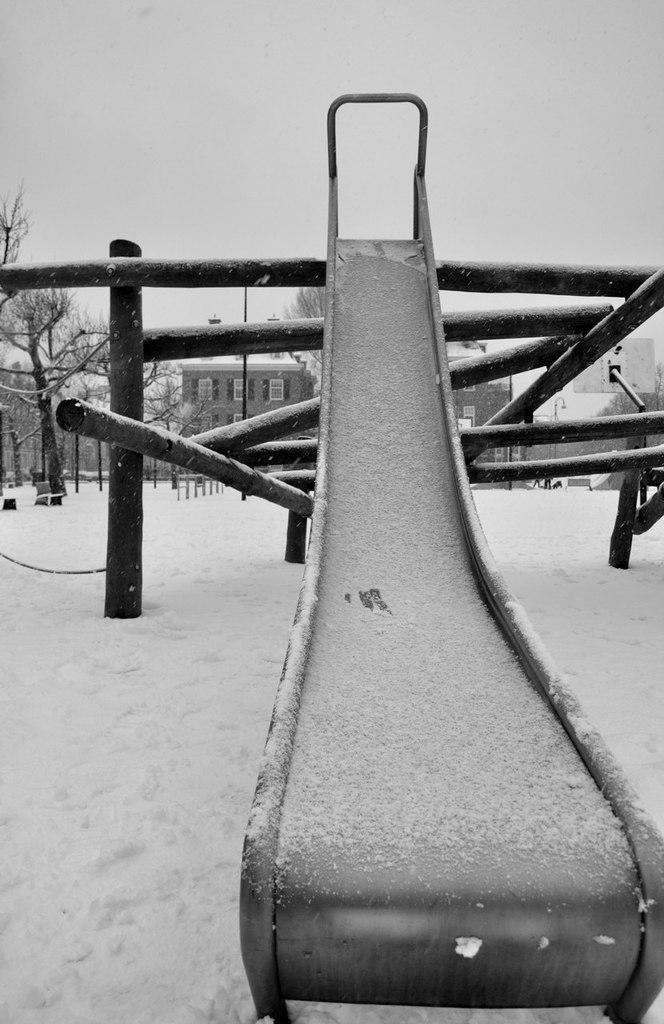What is the color scheme of the image? The image is black and white. What type of objects can be seen in the image? There are metal rods and other objects in the image. What type of playground equipment is present in the image? There is a slide in the image. What can be seen in the background of the image? Buildings and trees are visible in the background. What is the condition of the ground in the image? The ground is covered in snow. What type of produce is being harvested by the giants in the image? There are no giants or produce present in the image. What type of creature is interacting with the slide in the image? There is no creature interacting with the slide in the image; it is a playground structure. 